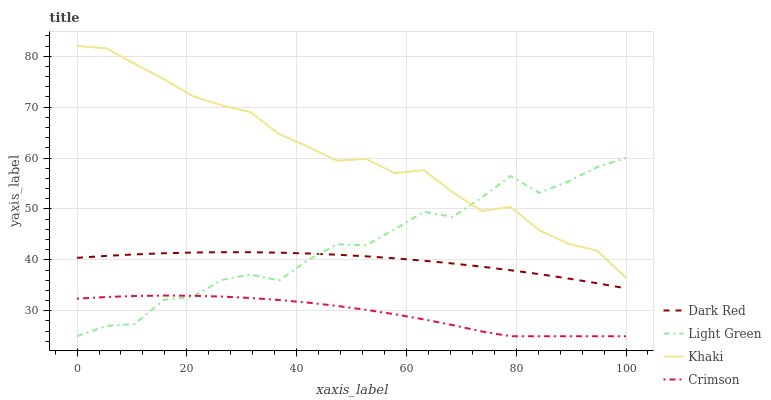Does Crimson have the minimum area under the curve?
Answer yes or no. Yes. Does Khaki have the maximum area under the curve?
Answer yes or no. Yes. Does Dark Red have the minimum area under the curve?
Answer yes or no. No. Does Dark Red have the maximum area under the curve?
Answer yes or no. No. Is Dark Red the smoothest?
Answer yes or no. Yes. Is Light Green the roughest?
Answer yes or no. Yes. Is Khaki the smoothest?
Answer yes or no. No. Is Khaki the roughest?
Answer yes or no. No. Does Crimson have the lowest value?
Answer yes or no. Yes. Does Dark Red have the lowest value?
Answer yes or no. No. Does Khaki have the highest value?
Answer yes or no. Yes. Does Dark Red have the highest value?
Answer yes or no. No. Is Dark Red less than Khaki?
Answer yes or no. Yes. Is Khaki greater than Dark Red?
Answer yes or no. Yes. Does Crimson intersect Light Green?
Answer yes or no. Yes. Is Crimson less than Light Green?
Answer yes or no. No. Is Crimson greater than Light Green?
Answer yes or no. No. Does Dark Red intersect Khaki?
Answer yes or no. No. 